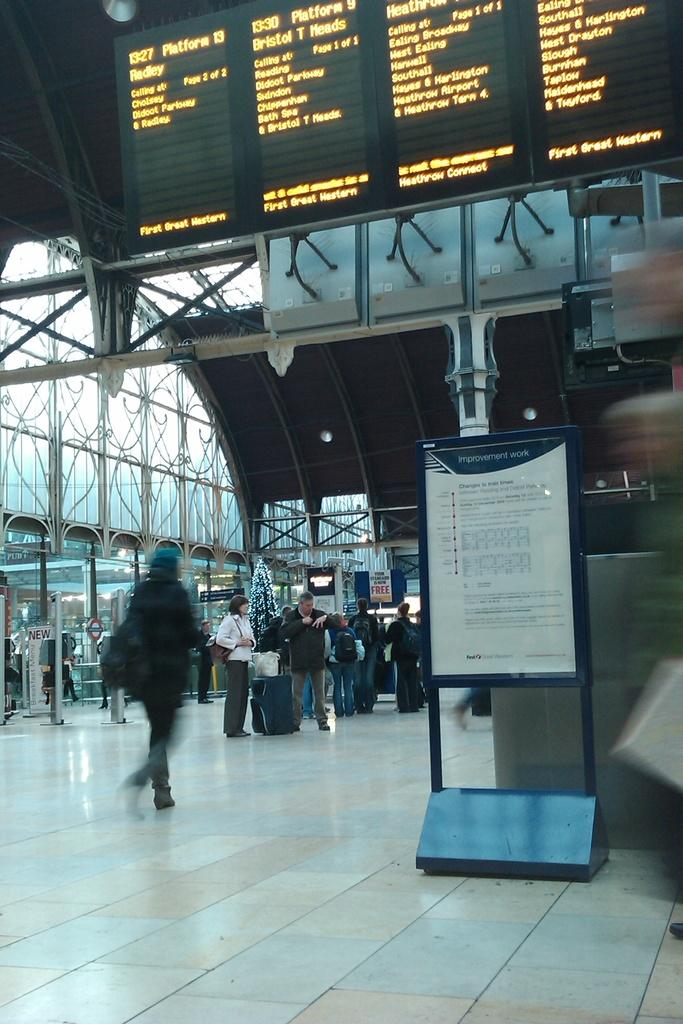How many people are in the image? There are persons standing in the image. What surface are the persons standing on? The persons are standing on the floor. What is written at the top of the image? There is text visible at the top of the image. What object in the image has text on it? There is a board with text in the image. How many oranges are being pushed by the persons in the image? There are no oranges present in the image, and the persons are not pushing anything. What type of harmony is being displayed by the persons in the image? The image does not depict any specific type of harmony; it simply shows persons standing on the floor. 